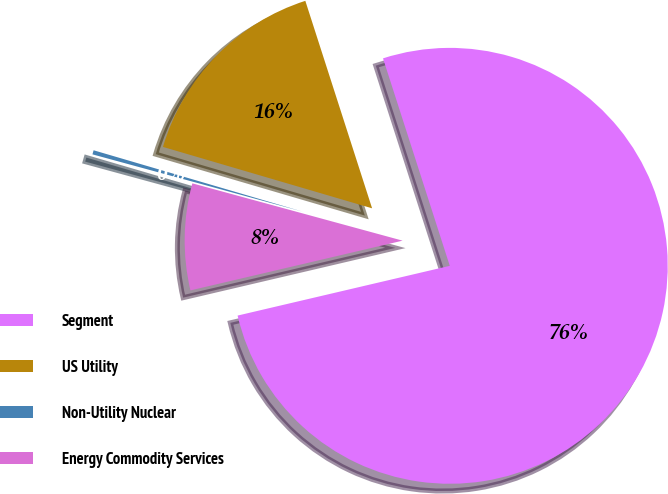Convert chart. <chart><loc_0><loc_0><loc_500><loc_500><pie_chart><fcel>Segment<fcel>US Utility<fcel>Non-Utility Nuclear<fcel>Energy Commodity Services<nl><fcel>76.29%<fcel>15.5%<fcel>0.31%<fcel>7.9%<nl></chart> 